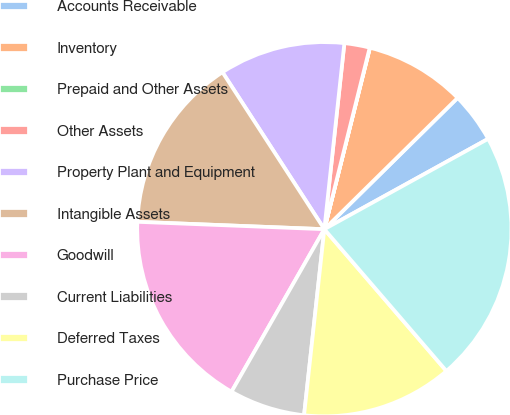Convert chart. <chart><loc_0><loc_0><loc_500><loc_500><pie_chart><fcel>Accounts Receivable<fcel>Inventory<fcel>Prepaid and Other Assets<fcel>Other Assets<fcel>Property Plant and Equipment<fcel>Intangible Assets<fcel>Goodwill<fcel>Current Liabilities<fcel>Deferred Taxes<fcel>Purchase Price<nl><fcel>4.36%<fcel>8.7%<fcel>0.02%<fcel>2.19%<fcel>10.87%<fcel>15.21%<fcel>17.37%<fcel>6.53%<fcel>13.04%<fcel>21.71%<nl></chart> 